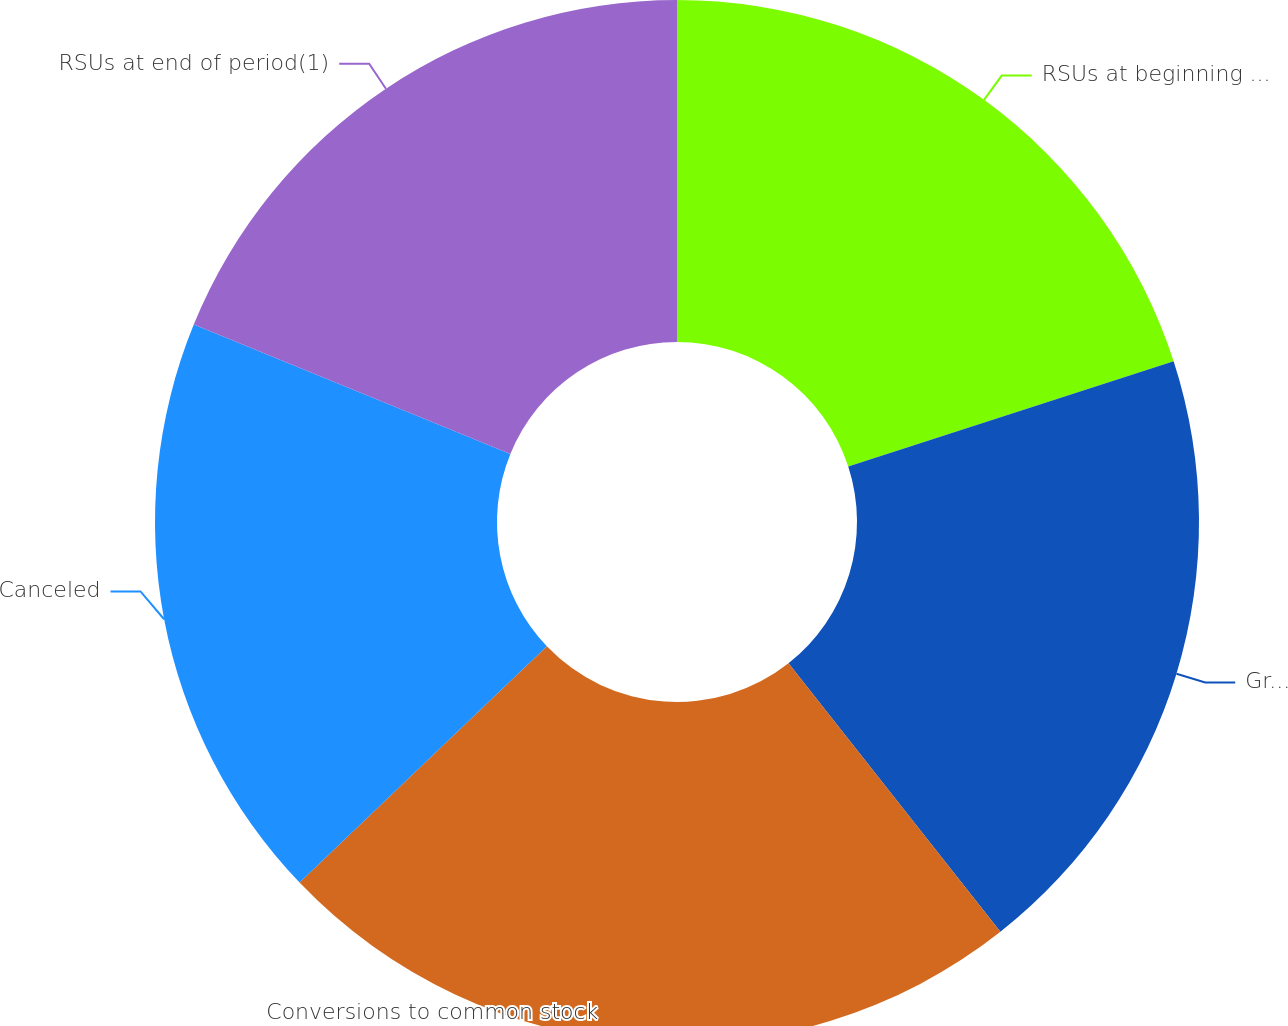Convert chart to OTSL. <chart><loc_0><loc_0><loc_500><loc_500><pie_chart><fcel>RSUs at beginning of period<fcel>Granted<fcel>Conversions to common stock<fcel>Canceled<fcel>RSUs at end of period(1)<nl><fcel>20.02%<fcel>19.35%<fcel>23.5%<fcel>18.31%<fcel>18.83%<nl></chart> 